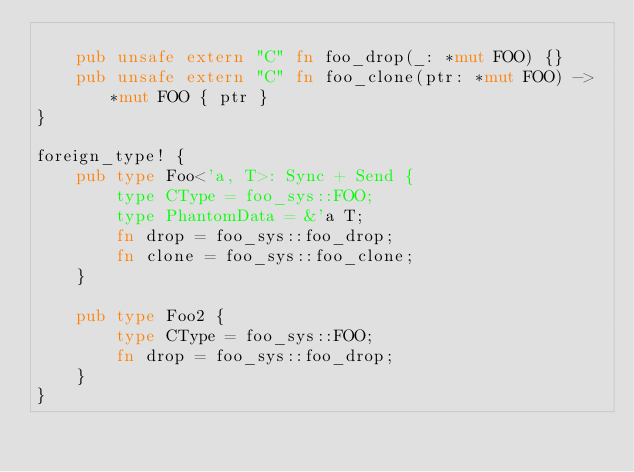Convert code to text. <code><loc_0><loc_0><loc_500><loc_500><_Rust_>
    pub unsafe extern "C" fn foo_drop(_: *mut FOO) {}
    pub unsafe extern "C" fn foo_clone(ptr: *mut FOO) -> *mut FOO { ptr }
}

foreign_type! {
    pub type Foo<'a, T>: Sync + Send {
        type CType = foo_sys::FOO;
        type PhantomData = &'a T;
        fn drop = foo_sys::foo_drop;
        fn clone = foo_sys::foo_clone;
    }

    pub type Foo2 {
        type CType = foo_sys::FOO;
        fn drop = foo_sys::foo_drop;
    }
}
</code> 